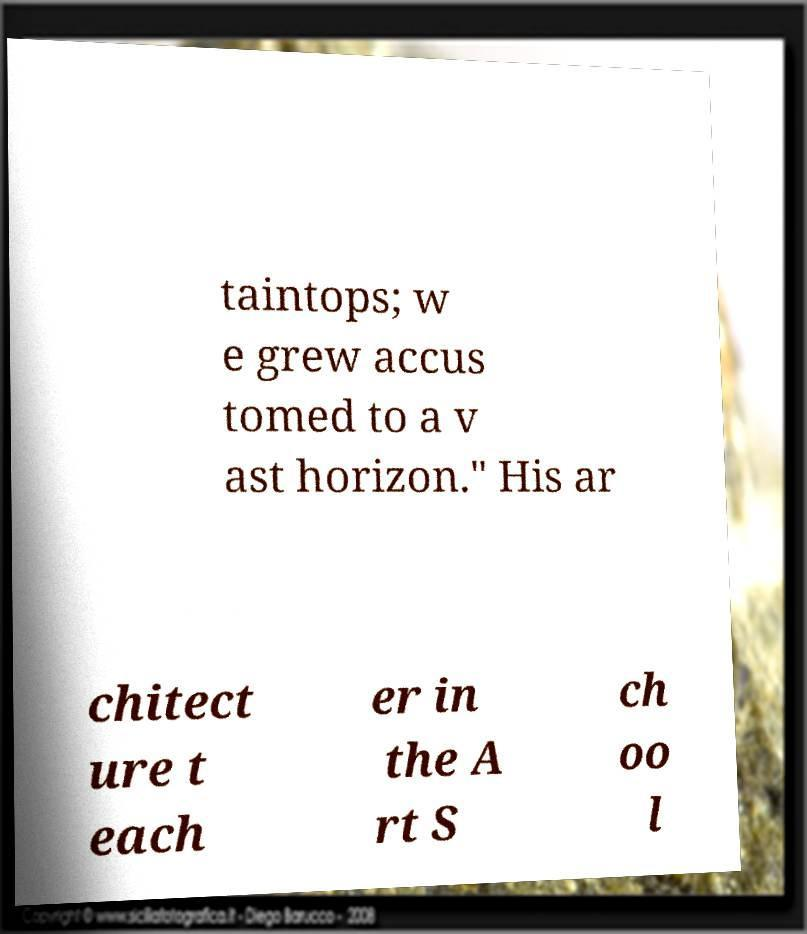For documentation purposes, I need the text within this image transcribed. Could you provide that? taintops; w e grew accus tomed to a v ast horizon." His ar chitect ure t each er in the A rt S ch oo l 